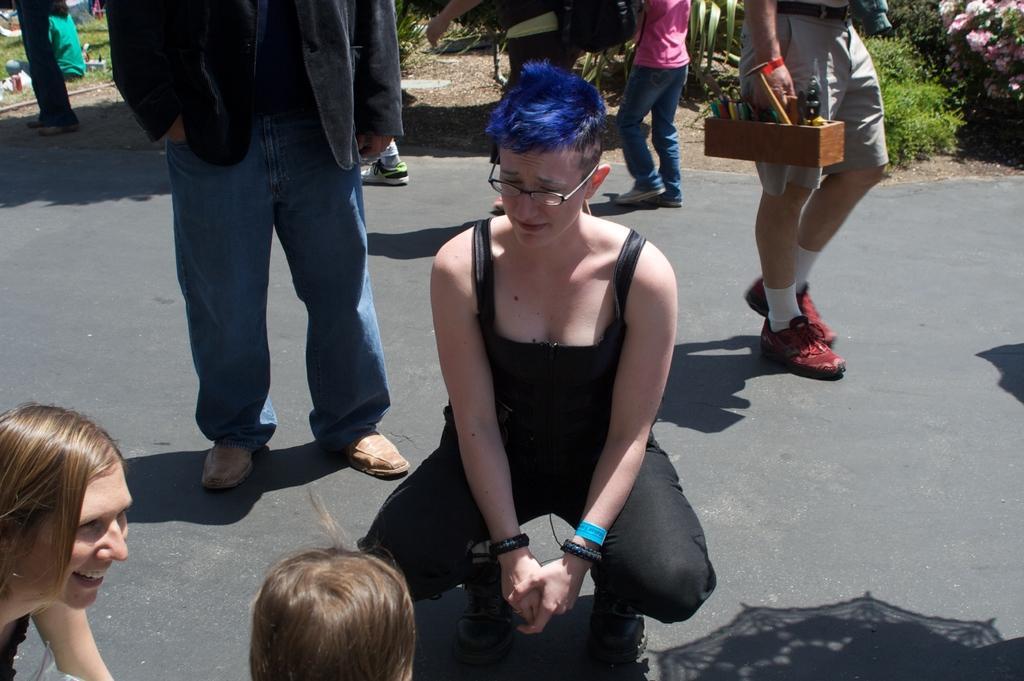Please provide a concise description of this image. This picture describes about group of people, in the middle of the image we can see a woman she wore spectacles, in the background we can find few plants and flowers. 